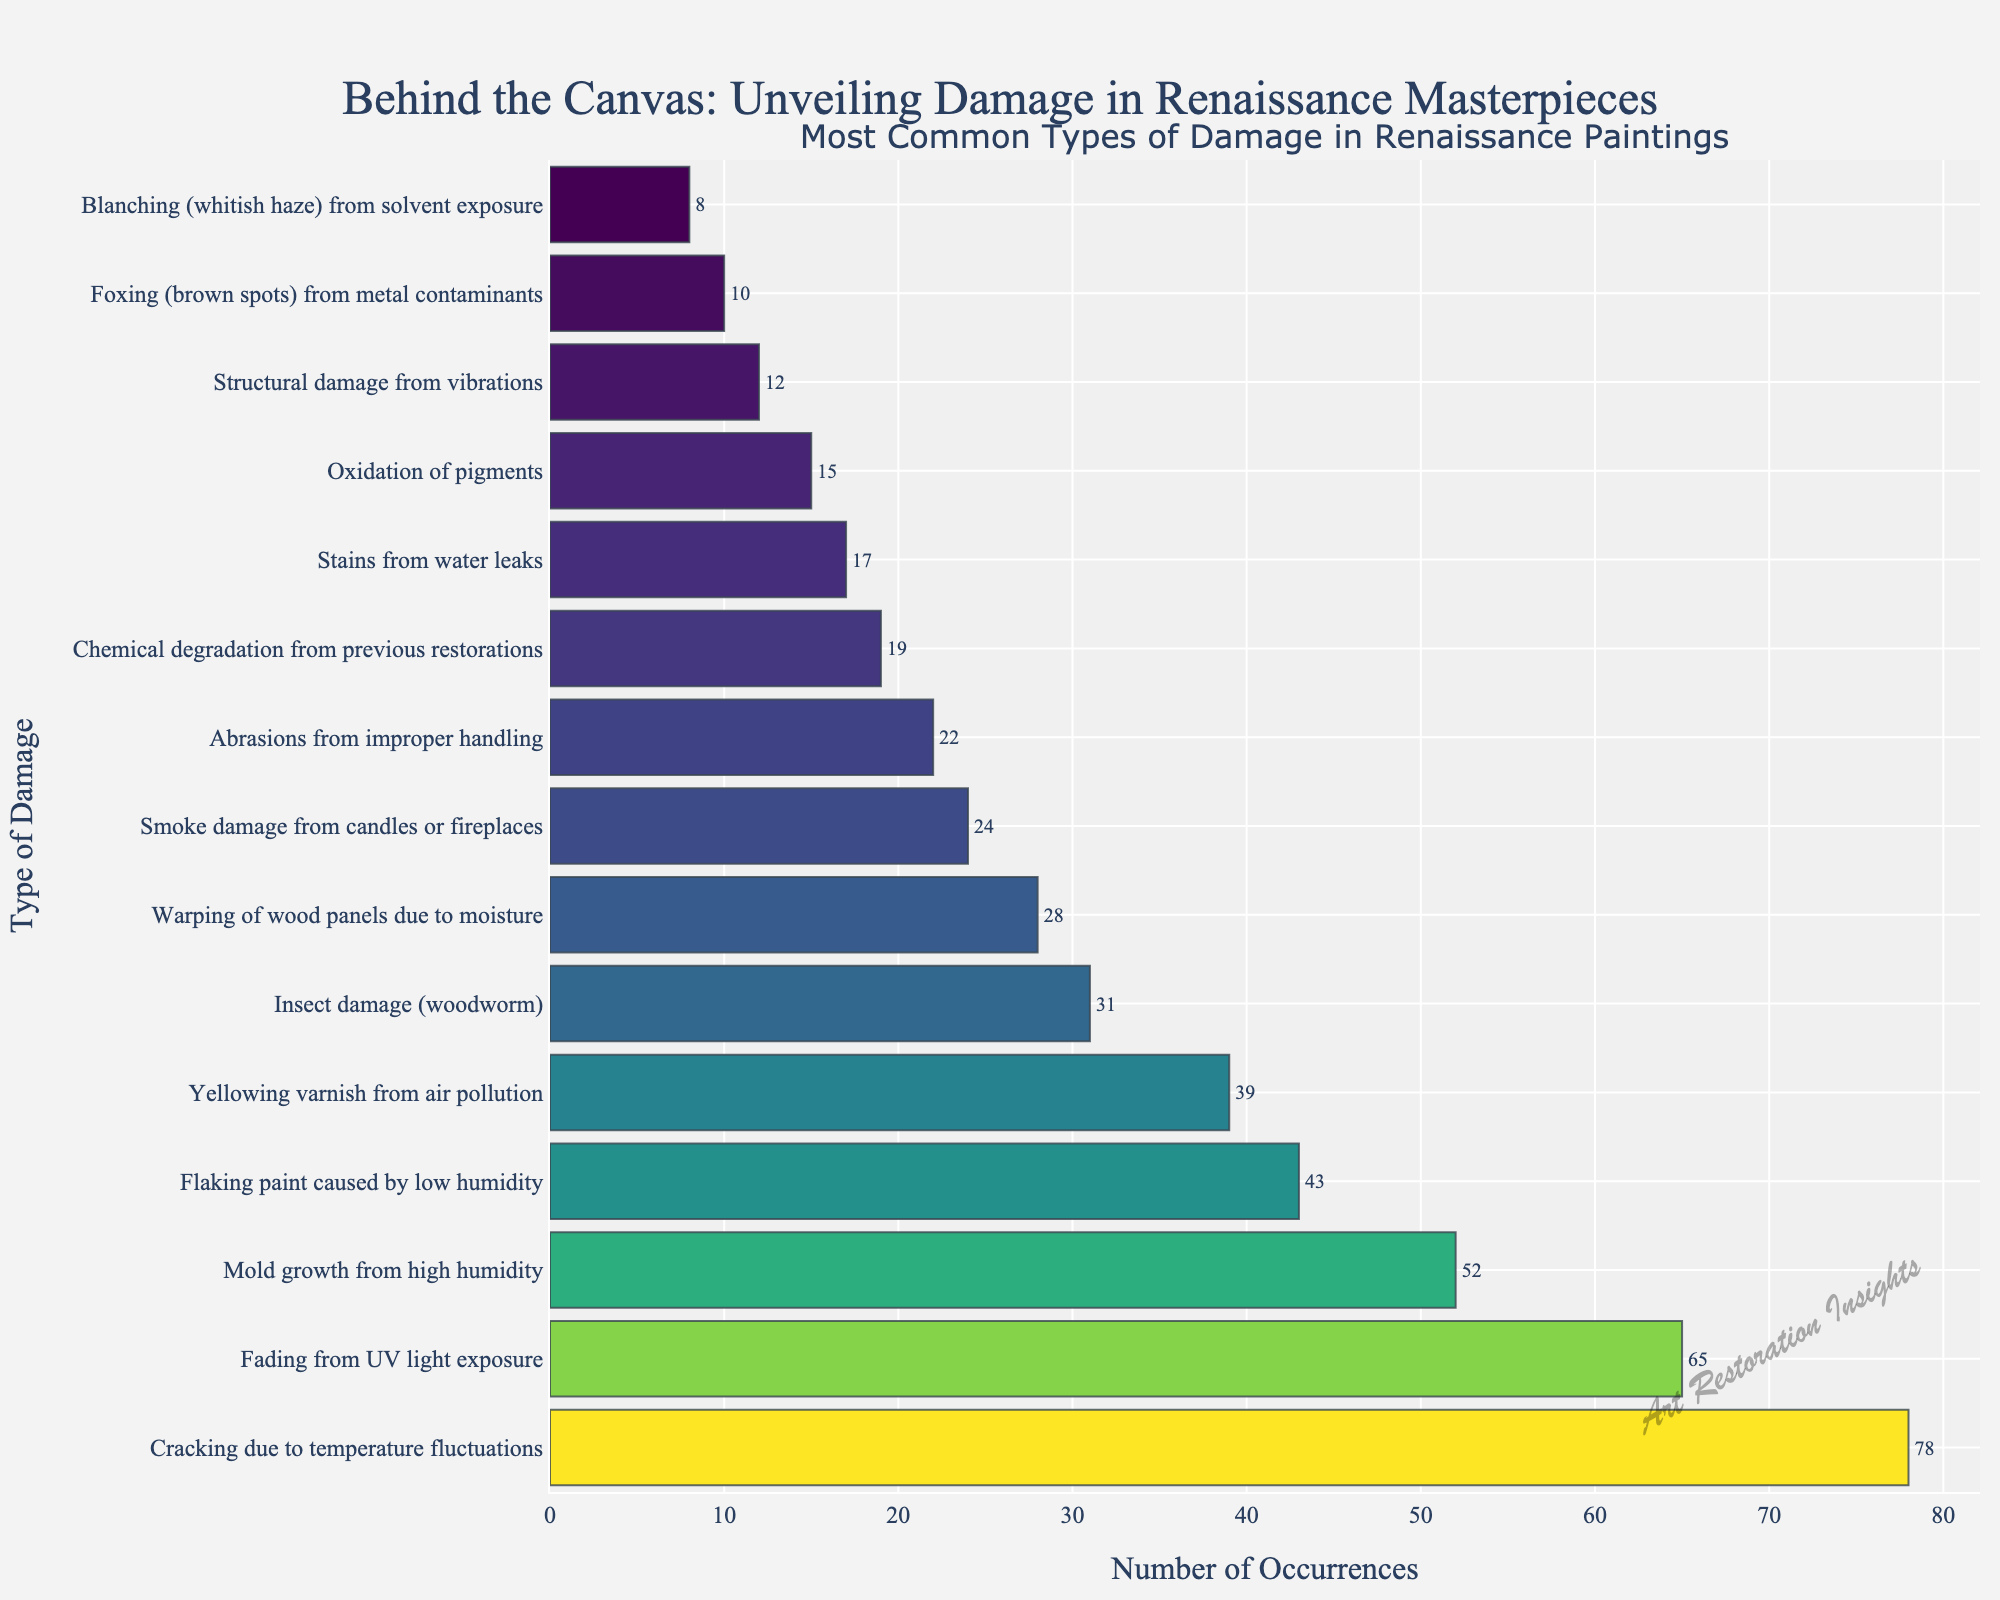Which type of damage is most common in Renaissance paintings? The bar representing "Cracking due to temperature fluctuations" is the longest, indicating it has the highest number of occurrences.
Answer: Cracking due to temperature fluctuations What is the total number of occurrences for the top three types of damage combined? The top three types of damage are "Cracking due to temperature fluctuations" (78), "Fading from UV light exposure" (65), and "Mold growth from high humidity" (52). Summing these: 78 + 65 + 52 = 195.
Answer: 195 Which environmental factor causes more damage, high humidity or low humidity? High humidity causes "Mold growth" with 52 occurrences; low humidity causes "Flaking paint" with 43 occurrences. Since 52 is greater than 43, high humidity causes more damage.
Answer: High humidity Are there more occurrences of "Yellowing varnish from air pollution" or "Insect damage (woodworm)"? By comparing the lengths of the bars, "Yellowing varnish from air pollution" has 39 occurrences while "Insect damage (woodworm)" has 31. Since 39 is greater than 31, yellowing varnish from air pollution is more common.
Answer: Yellowing varnish from air pollution What is the median number of occurrences for all types of damage? First, list out the number of occurrences in ascending order (8, 10, 12, 15, 17, 19, 22, 24, 28, 31, 39, 43, 52, 65, 78). Since there are 15 data points, the median is the 8th value, which is 22.
Answer: 22 How many more occurrences does "Warping of wood panels due to moisture" have compared to "Structural damage from vibrations"? "Warping of wood panels due to moisture" has 28 occurrences and "Structural damage from vibrations" has 12. The difference is 28 - 12 = 16.
Answer: 16 Which type of damage has the least number of occurrences? The shortest bar belongs to "Blanching (whitish haze) from solvent exposure," indicating it has the fewest occurrences, which is 8.
Answer: Blanching (whitish haze) from solvent exposure What is the average number of occurrences for all listed types of damage? Sum all the occurrences (78 + 65 + 52 + 43 + 39 + 31 + 28 + 24 + 22 + 19 + 17 + 15 + 12 + 10 + 8 = 463). There are 15 types of damage, so the average is 463 / 15 = 30.87.
Answer: 30.87 Between "Smoke damage from candles or fireplaces" and "Abrasions from improper handling," which has more occurrences and by how much? "Smoke damage from candles or fireplaces" has 24 occurrences and "Abrasions from improper handling" has 22. The difference is 24 - 22 = 2.
Answer: Smoke damage from candles or fireplaces, by 2 How many types of damage have occurrences greater than 30? By checking the lengths of the bars, the types are "Cracking due to temperature fluctuations" (78), "Fading from UV light exposure" (65), "Mold growth from high humidity" (52), "Flaking paint caused by low humidity" (43), "Yellowing varnish from air pollution" (39), and "Insect damage (woodworm)" (31). Thus, there are 6 types of damage with occurrences greater than 30.
Answer: 6 